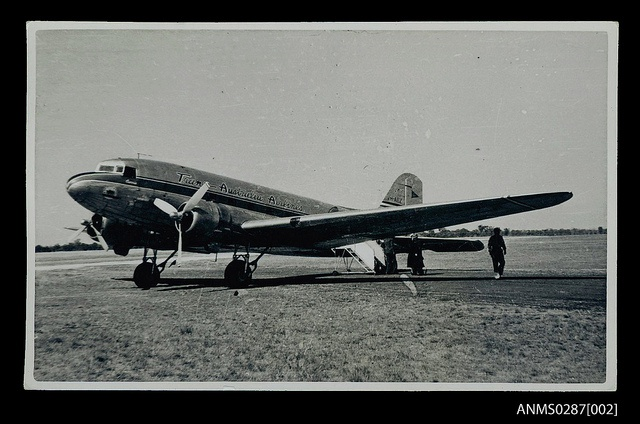Describe the objects in this image and their specific colors. I can see airplane in black, gray, darkgray, and purple tones, people in black, gray, darkgray, and purple tones, and people in black, gray, darkgray, and purple tones in this image. 